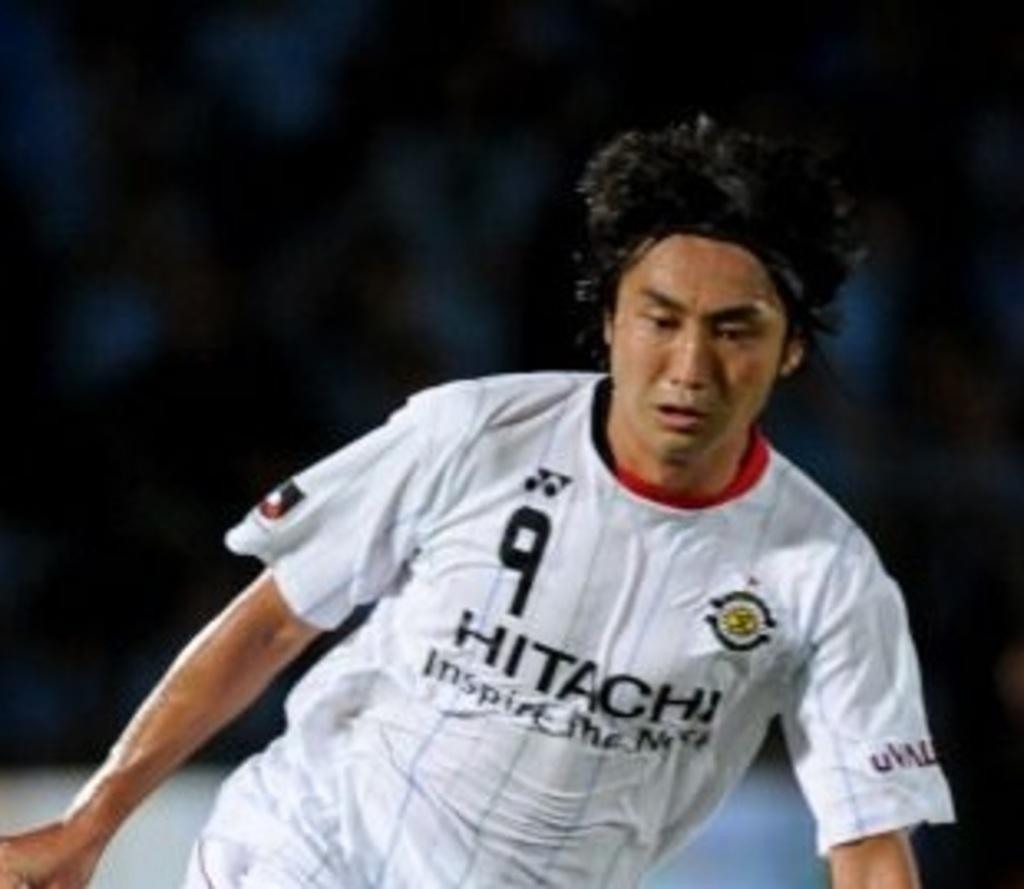Who or what is the main subject in the image? There is a person in the image. What is the person wearing? The person is wearing a T-shirt. Can you describe the background of the image? The background of the image is blurred. How many cacti can be seen in the image? There are no cacti present in the image. What type of bridge is visible in the background of the image? There is no bridge visible in the image, as the background is blurred. 